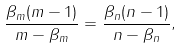Convert formula to latex. <formula><loc_0><loc_0><loc_500><loc_500>\frac { \beta _ { m } ( m - 1 ) } { m - \beta _ { m } } = \frac { \beta _ { n } ( n - 1 ) } { n - \beta _ { n } } ,</formula> 